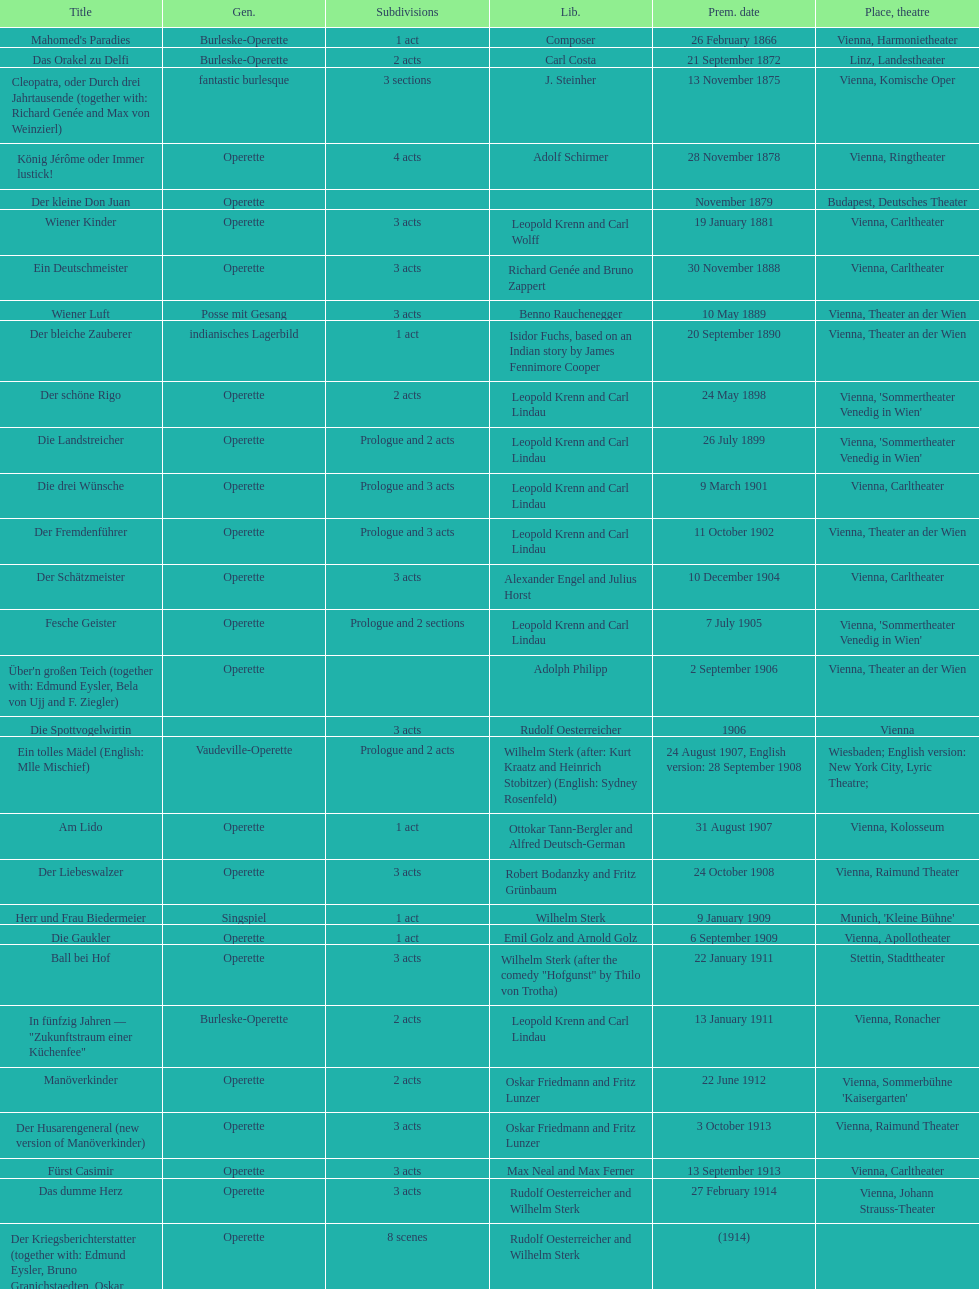How many of his operettas were 3 acts? 13. 